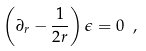Convert formula to latex. <formula><loc_0><loc_0><loc_500><loc_500>\left ( \partial _ { r } - \frac { 1 } { 2 r } \right ) \epsilon = 0 \ ,</formula> 